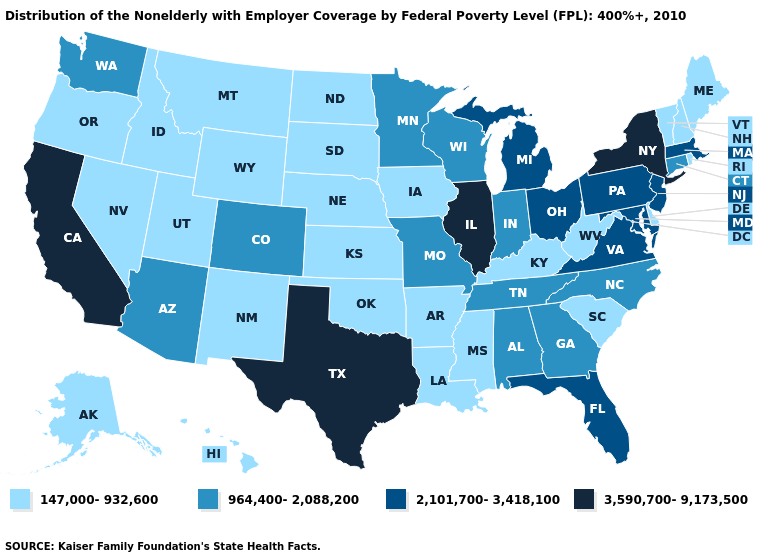Does Florida have the lowest value in the South?
Concise answer only. No. Does the map have missing data?
Answer briefly. No. Does California have the highest value in the West?
Keep it brief. Yes. What is the highest value in the USA?
Give a very brief answer. 3,590,700-9,173,500. Does Oklahoma have the lowest value in the USA?
Quick response, please. Yes. Name the states that have a value in the range 2,101,700-3,418,100?
Give a very brief answer. Florida, Maryland, Massachusetts, Michigan, New Jersey, Ohio, Pennsylvania, Virginia. Which states have the highest value in the USA?
Write a very short answer. California, Illinois, New York, Texas. Name the states that have a value in the range 2,101,700-3,418,100?
Quick response, please. Florida, Maryland, Massachusetts, Michigan, New Jersey, Ohio, Pennsylvania, Virginia. What is the value of Utah?
Quick response, please. 147,000-932,600. What is the lowest value in states that border Wyoming?
Give a very brief answer. 147,000-932,600. Does Pennsylvania have a lower value than Texas?
Keep it brief. Yes. What is the highest value in states that border Kansas?
Concise answer only. 964,400-2,088,200. What is the lowest value in the USA?
Quick response, please. 147,000-932,600. Does California have the highest value in the West?
Write a very short answer. Yes. Name the states that have a value in the range 3,590,700-9,173,500?
Concise answer only. California, Illinois, New York, Texas. 